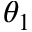<formula> <loc_0><loc_0><loc_500><loc_500>\theta _ { 1 }</formula> 